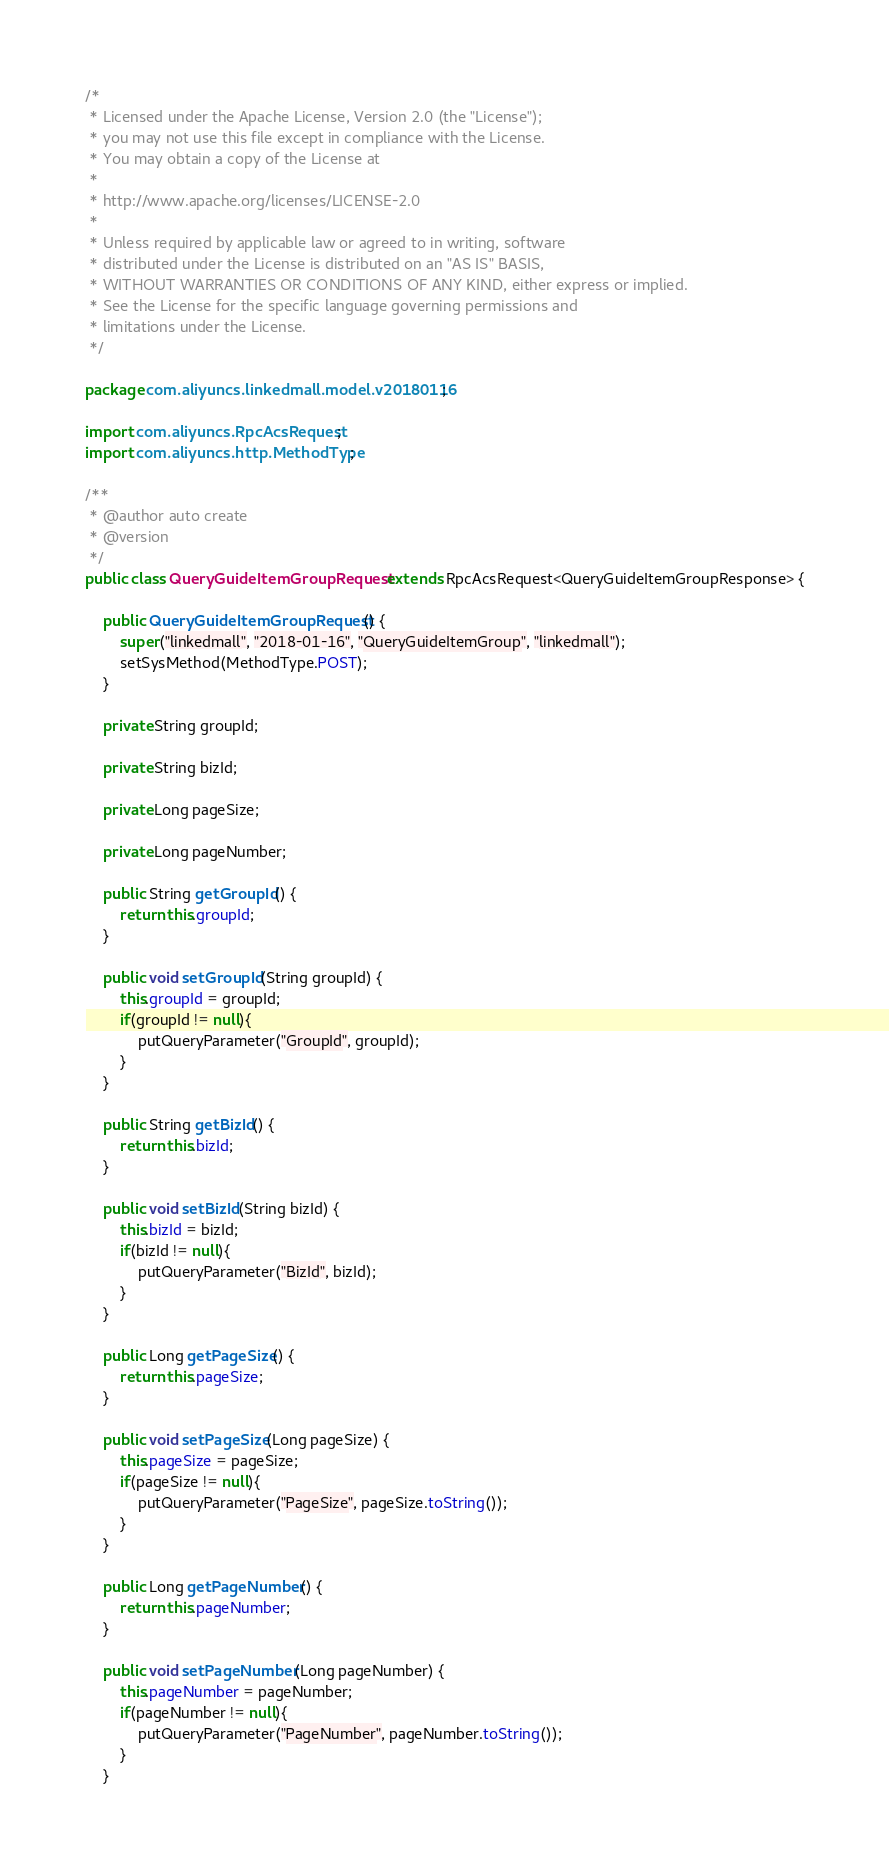Convert code to text. <code><loc_0><loc_0><loc_500><loc_500><_Java_>/*
 * Licensed under the Apache License, Version 2.0 (the "License");
 * you may not use this file except in compliance with the License.
 * You may obtain a copy of the License at
 *
 * http://www.apache.org/licenses/LICENSE-2.0
 *
 * Unless required by applicable law or agreed to in writing, software
 * distributed under the License is distributed on an "AS IS" BASIS,
 * WITHOUT WARRANTIES OR CONDITIONS OF ANY KIND, either express or implied.
 * See the License for the specific language governing permissions and
 * limitations under the License.
 */

package com.aliyuncs.linkedmall.model.v20180116;

import com.aliyuncs.RpcAcsRequest;
import com.aliyuncs.http.MethodType;

/**
 * @author auto create
 * @version 
 */
public class QueryGuideItemGroupRequest extends RpcAcsRequest<QueryGuideItemGroupResponse> {
	
	public QueryGuideItemGroupRequest() {
		super("linkedmall", "2018-01-16", "QueryGuideItemGroup", "linkedmall");
		setSysMethod(MethodType.POST);
	}

	private String groupId;

	private String bizId;

	private Long pageSize;

	private Long pageNumber;

	public String getGroupId() {
		return this.groupId;
	}

	public void setGroupId(String groupId) {
		this.groupId = groupId;
		if(groupId != null){
			putQueryParameter("GroupId", groupId);
		}
	}

	public String getBizId() {
		return this.bizId;
	}

	public void setBizId(String bizId) {
		this.bizId = bizId;
		if(bizId != null){
			putQueryParameter("BizId", bizId);
		}
	}

	public Long getPageSize() {
		return this.pageSize;
	}

	public void setPageSize(Long pageSize) {
		this.pageSize = pageSize;
		if(pageSize != null){
			putQueryParameter("PageSize", pageSize.toString());
		}
	}

	public Long getPageNumber() {
		return this.pageNumber;
	}

	public void setPageNumber(Long pageNumber) {
		this.pageNumber = pageNumber;
		if(pageNumber != null){
			putQueryParameter("PageNumber", pageNumber.toString());
		}
	}
</code> 